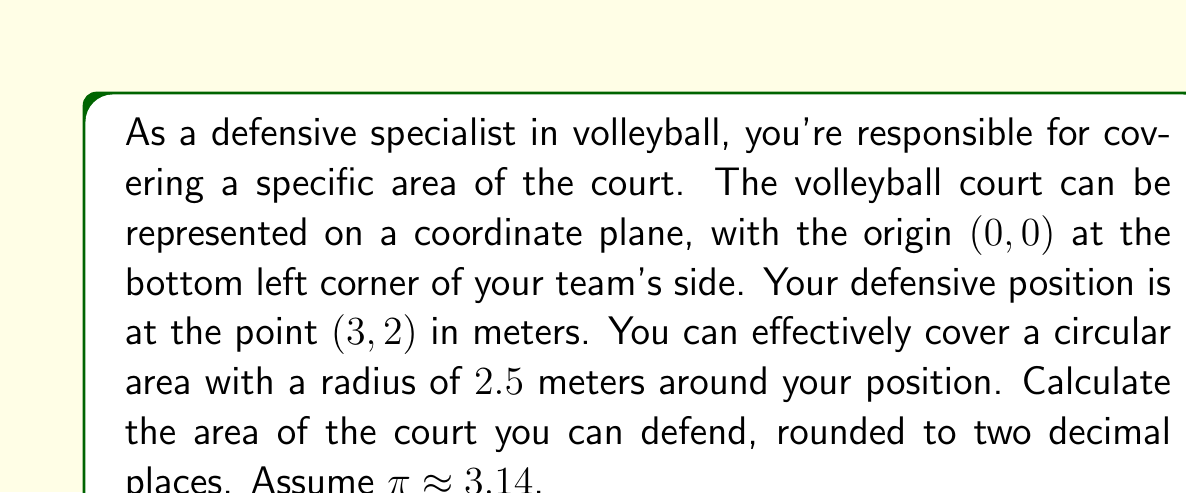Solve this math problem. To solve this problem, we'll use the formula for the area of a circle:

$$ A = \pi r^2 $$

Where:
$A$ is the area
$\pi$ is approximately 3.14
$r$ is the radius of the circle

Given:
- Your position is at (3,2) on the coordinate plane
- Your effective coverage radius is 2.5 meters

Steps:
1. Identify the radius: $r = 2.5$ meters

2. Substitute the values into the formula:
   $$ A = \pi r^2 $$
   $$ A = 3.14 \times (2.5)^2 $$

3. Calculate the result:
   $$ A = 3.14 \times 6.25 $$
   $$ A = 19.625 \text{ square meters} $$

4. Round to two decimal places:
   $$ A \approx 19.63 \text{ square meters} $$

This area represents the circular region on the court that you can effectively defend from your position.

[asy]
import geometry;

size(200);
draw((-1,-1)--(7,-1)--(7,5)--(-1,5)--cycle);
dot((3,2),red);
draw(circle((3,2),2.5),blue);
label("(3,2)",(3,2),NE);
label("2.5m",((3,2)+2.5*dir(45)),NE);
[/asy]
Answer: 19.63 square meters 